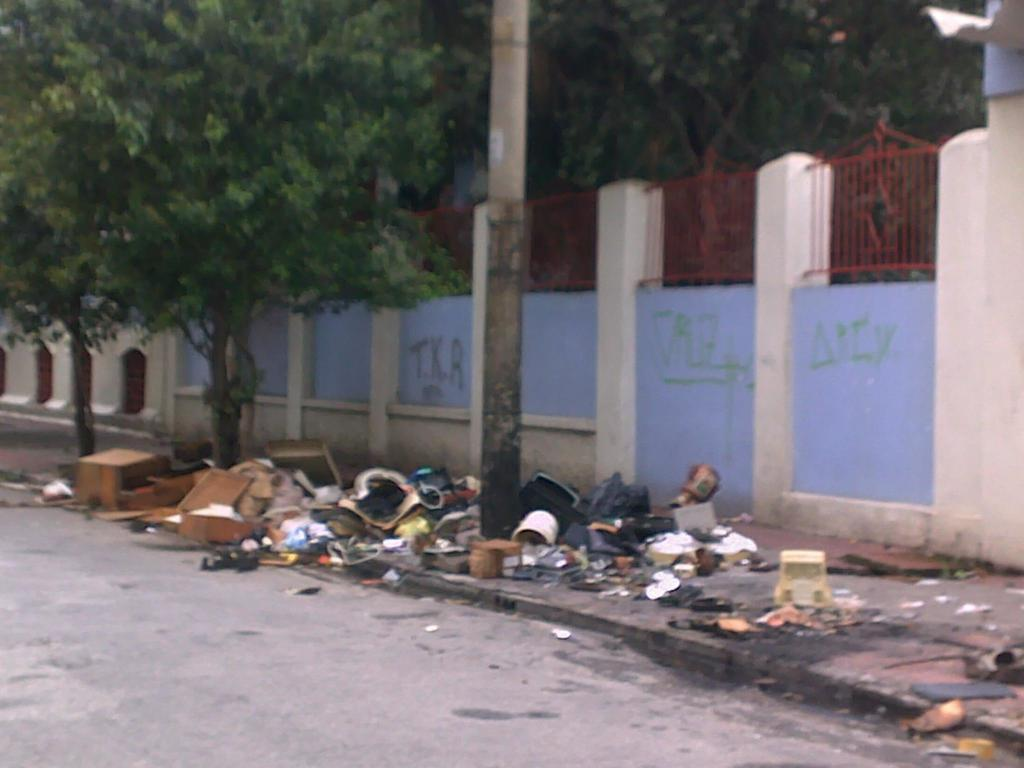What can be seen on the pathway in the image? There is scrap on the pathway in the image. What type of vegetation is present in the image? There is a group of trees in the image. What is written on the wall in the image? There is a wall with written text in the image. What feature can be seen for safety or support in the image? There is a railing in the image. How many horses are visible in the image? There are no horses present in the image. What type of body is depicted on the wall in the image? There is no body depicted on the wall in the image; it has written text. 